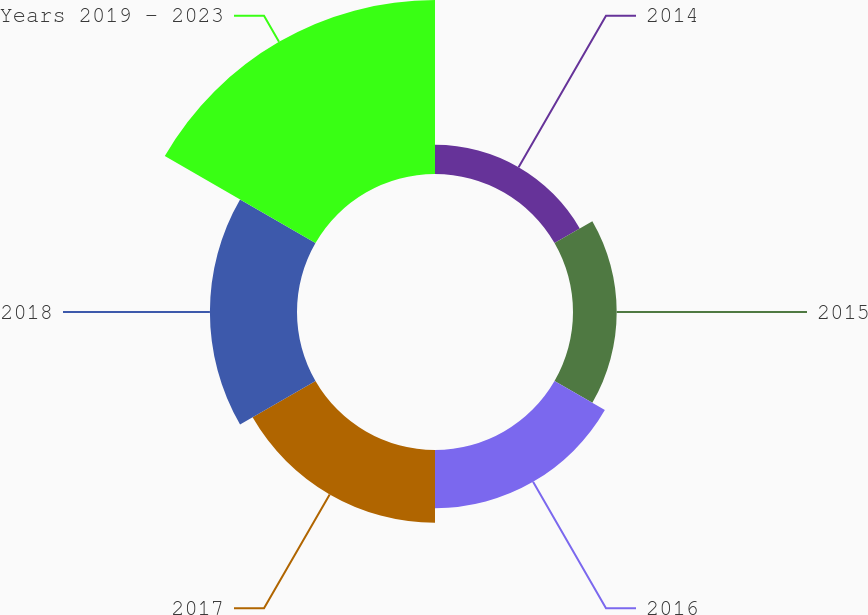Convert chart to OTSL. <chart><loc_0><loc_0><loc_500><loc_500><pie_chart><fcel>2014<fcel>2015<fcel>2016<fcel>2017<fcel>2018<fcel>Years 2019 - 2023<nl><fcel>6.28%<fcel>9.4%<fcel>12.51%<fcel>15.63%<fcel>18.74%<fcel>37.44%<nl></chart> 